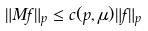<formula> <loc_0><loc_0><loc_500><loc_500>\| M f \| _ { p } \leq c ( p , \mu ) \| f \| _ { p }</formula> 